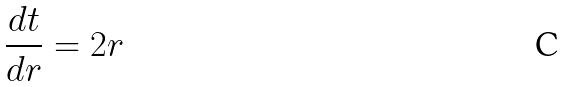Convert formula to latex. <formula><loc_0><loc_0><loc_500><loc_500>\frac { d t } { d r } = 2 r</formula> 